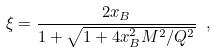Convert formula to latex. <formula><loc_0><loc_0><loc_500><loc_500>\xi = \frac { 2 x _ { B } } { 1 + \sqrt { 1 + 4 x _ { B } ^ { 2 } M ^ { 2 } / Q ^ { 2 } } } \ ,</formula> 